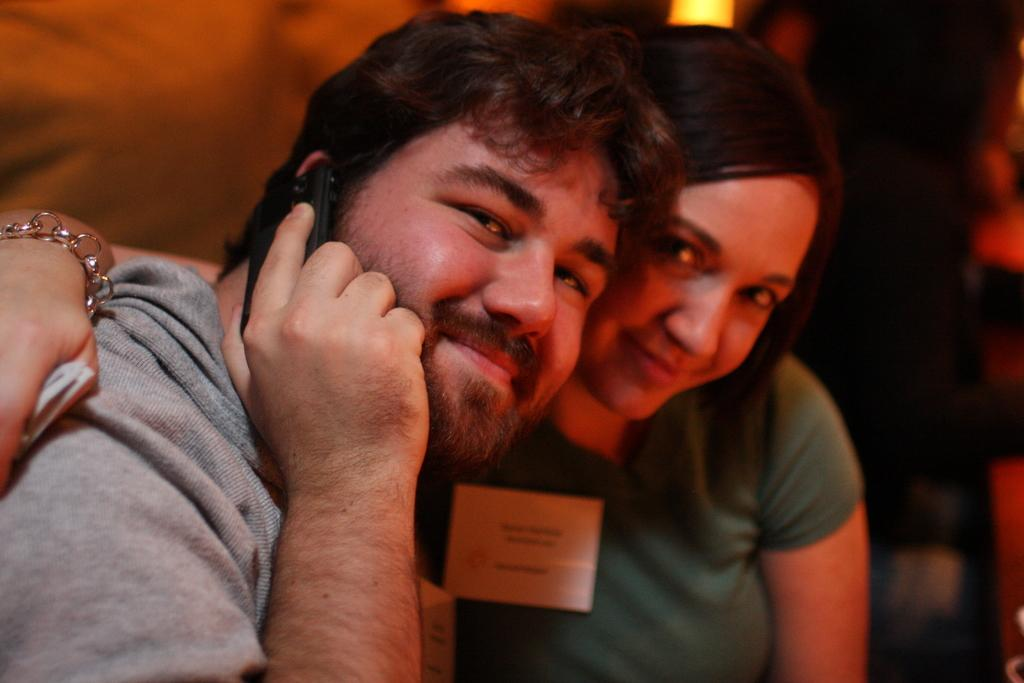Who is present in the image? There is a couple in the image. What are the couple doing in the image? Both individuals in the couple are smiling. What object is the person on the left side holding? The person on the left side is holding a mobile phone in his hand. Can you see a tiger walking on the floor in the image? No, there is no tiger or floor visible in the image. What is the couple saying to each other as they say good-bye in the image? There is no indication in the image that the couple is saying good-bye or engaging in any conversation. 